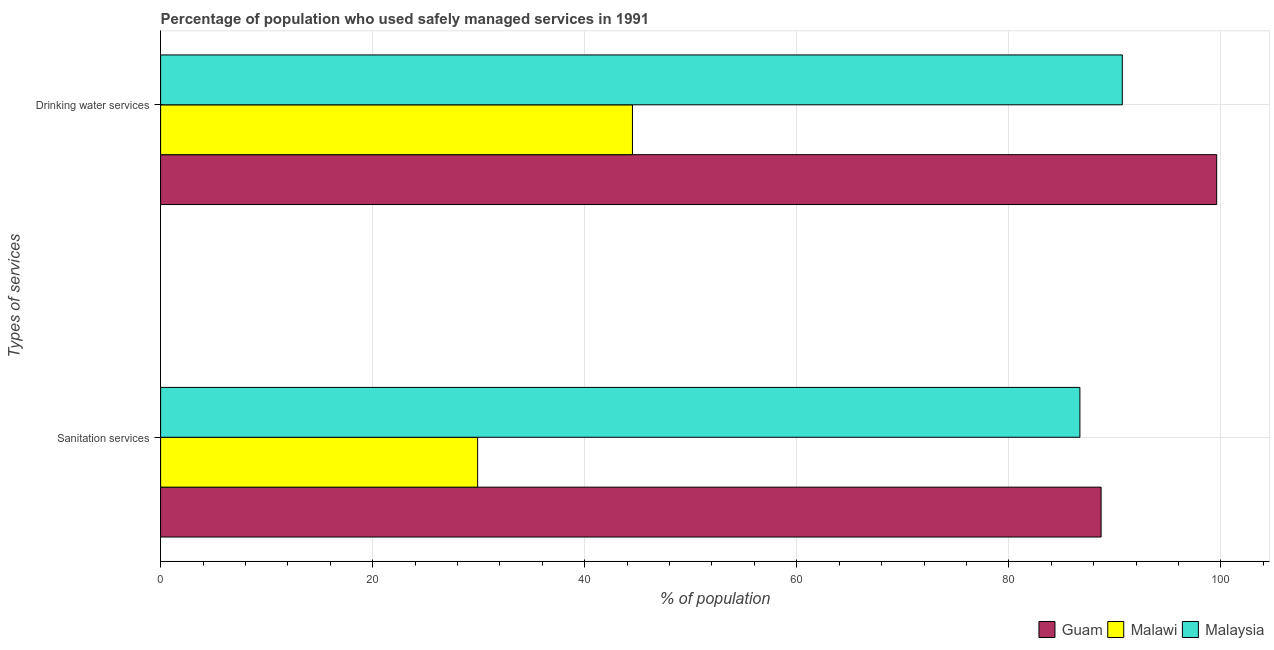How many groups of bars are there?
Your answer should be compact. 2. Are the number of bars per tick equal to the number of legend labels?
Provide a succinct answer. Yes. How many bars are there on the 2nd tick from the bottom?
Make the answer very short. 3. What is the label of the 2nd group of bars from the top?
Ensure brevity in your answer.  Sanitation services. What is the percentage of population who used drinking water services in Malaysia?
Your answer should be very brief. 90.7. Across all countries, what is the maximum percentage of population who used drinking water services?
Keep it short and to the point. 99.6. Across all countries, what is the minimum percentage of population who used drinking water services?
Keep it short and to the point. 44.5. In which country was the percentage of population who used drinking water services maximum?
Provide a short and direct response. Guam. In which country was the percentage of population who used sanitation services minimum?
Give a very brief answer. Malawi. What is the total percentage of population who used sanitation services in the graph?
Give a very brief answer. 205.3. What is the difference between the percentage of population who used sanitation services in Malaysia and that in Guam?
Give a very brief answer. -2. What is the difference between the percentage of population who used sanitation services in Malawi and the percentage of population who used drinking water services in Malaysia?
Offer a very short reply. -60.8. What is the average percentage of population who used sanitation services per country?
Give a very brief answer. 68.43. What is the difference between the percentage of population who used sanitation services and percentage of population who used drinking water services in Malaysia?
Your answer should be compact. -4. In how many countries, is the percentage of population who used sanitation services greater than 56 %?
Make the answer very short. 2. What is the ratio of the percentage of population who used sanitation services in Guam to that in Malawi?
Keep it short and to the point. 2.97. Is the percentage of population who used drinking water services in Guam less than that in Malawi?
Keep it short and to the point. No. What does the 1st bar from the top in Drinking water services represents?
Offer a terse response. Malaysia. What does the 3rd bar from the bottom in Sanitation services represents?
Offer a terse response. Malaysia. How many bars are there?
Provide a succinct answer. 6. Are all the bars in the graph horizontal?
Offer a very short reply. Yes. How many countries are there in the graph?
Provide a succinct answer. 3. What is the difference between two consecutive major ticks on the X-axis?
Offer a very short reply. 20. Are the values on the major ticks of X-axis written in scientific E-notation?
Provide a succinct answer. No. Does the graph contain any zero values?
Provide a succinct answer. No. Where does the legend appear in the graph?
Give a very brief answer. Bottom right. What is the title of the graph?
Offer a terse response. Percentage of population who used safely managed services in 1991. Does "Armenia" appear as one of the legend labels in the graph?
Your answer should be very brief. No. What is the label or title of the X-axis?
Your answer should be very brief. % of population. What is the label or title of the Y-axis?
Keep it short and to the point. Types of services. What is the % of population of Guam in Sanitation services?
Make the answer very short. 88.7. What is the % of population in Malawi in Sanitation services?
Provide a succinct answer. 29.9. What is the % of population of Malaysia in Sanitation services?
Offer a terse response. 86.7. What is the % of population of Guam in Drinking water services?
Give a very brief answer. 99.6. What is the % of population of Malawi in Drinking water services?
Provide a succinct answer. 44.5. What is the % of population in Malaysia in Drinking water services?
Your answer should be compact. 90.7. Across all Types of services, what is the maximum % of population of Guam?
Offer a very short reply. 99.6. Across all Types of services, what is the maximum % of population of Malawi?
Ensure brevity in your answer.  44.5. Across all Types of services, what is the maximum % of population in Malaysia?
Provide a succinct answer. 90.7. Across all Types of services, what is the minimum % of population in Guam?
Offer a very short reply. 88.7. Across all Types of services, what is the minimum % of population in Malawi?
Your response must be concise. 29.9. Across all Types of services, what is the minimum % of population in Malaysia?
Provide a short and direct response. 86.7. What is the total % of population in Guam in the graph?
Keep it short and to the point. 188.3. What is the total % of population in Malawi in the graph?
Offer a very short reply. 74.4. What is the total % of population of Malaysia in the graph?
Your answer should be compact. 177.4. What is the difference between the % of population of Malawi in Sanitation services and that in Drinking water services?
Provide a succinct answer. -14.6. What is the difference between the % of population in Guam in Sanitation services and the % of population in Malawi in Drinking water services?
Keep it short and to the point. 44.2. What is the difference between the % of population of Guam in Sanitation services and the % of population of Malaysia in Drinking water services?
Offer a terse response. -2. What is the difference between the % of population of Malawi in Sanitation services and the % of population of Malaysia in Drinking water services?
Your response must be concise. -60.8. What is the average % of population of Guam per Types of services?
Keep it short and to the point. 94.15. What is the average % of population in Malawi per Types of services?
Your response must be concise. 37.2. What is the average % of population in Malaysia per Types of services?
Your answer should be compact. 88.7. What is the difference between the % of population in Guam and % of population in Malawi in Sanitation services?
Offer a terse response. 58.8. What is the difference between the % of population in Malawi and % of population in Malaysia in Sanitation services?
Offer a very short reply. -56.8. What is the difference between the % of population in Guam and % of population in Malawi in Drinking water services?
Your answer should be very brief. 55.1. What is the difference between the % of population in Malawi and % of population in Malaysia in Drinking water services?
Ensure brevity in your answer.  -46.2. What is the ratio of the % of population in Guam in Sanitation services to that in Drinking water services?
Your response must be concise. 0.89. What is the ratio of the % of population in Malawi in Sanitation services to that in Drinking water services?
Your answer should be very brief. 0.67. What is the ratio of the % of population in Malaysia in Sanitation services to that in Drinking water services?
Offer a terse response. 0.96. What is the difference between the highest and the second highest % of population in Guam?
Make the answer very short. 10.9. What is the difference between the highest and the second highest % of population of Malawi?
Provide a succinct answer. 14.6. What is the difference between the highest and the second highest % of population of Malaysia?
Your answer should be compact. 4. What is the difference between the highest and the lowest % of population in Guam?
Your answer should be compact. 10.9. What is the difference between the highest and the lowest % of population of Malawi?
Provide a succinct answer. 14.6. What is the difference between the highest and the lowest % of population of Malaysia?
Your answer should be compact. 4. 